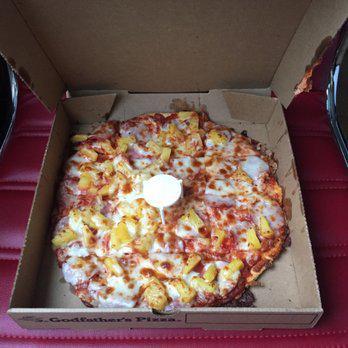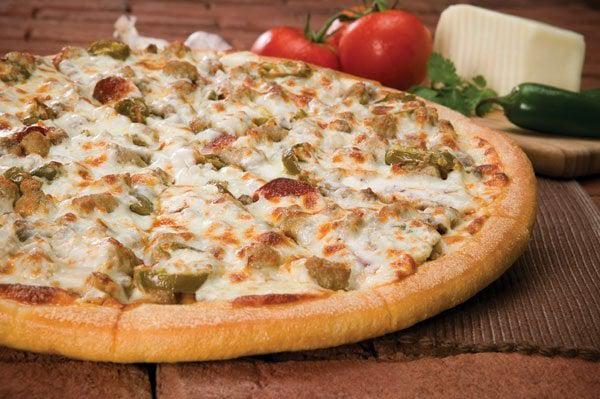The first image is the image on the left, the second image is the image on the right. For the images displayed, is the sentence "there is a pizza in a carboard box" factually correct? Answer yes or no. Yes. The first image is the image on the left, the second image is the image on the right. For the images shown, is this caption "Two whole baked pizzas are covered with toppings and melted cheese, one of them in a cardboard delivery box." true? Answer yes or no. Yes. 